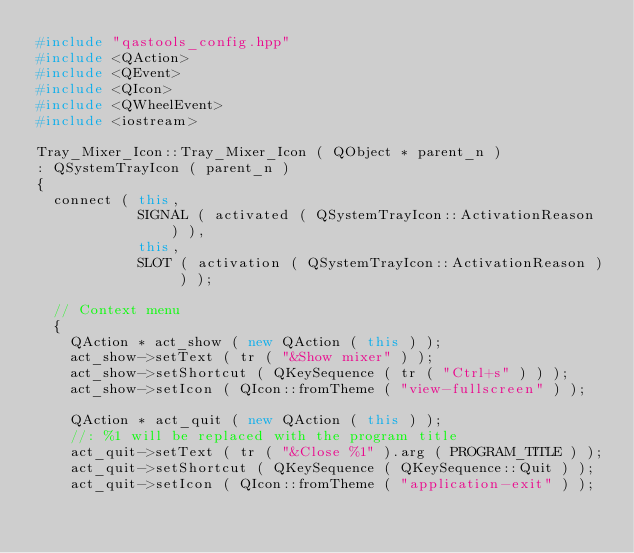<code> <loc_0><loc_0><loc_500><loc_500><_C++_>#include "qastools_config.hpp"
#include <QAction>
#include <QEvent>
#include <QIcon>
#include <QWheelEvent>
#include <iostream>

Tray_Mixer_Icon::Tray_Mixer_Icon ( QObject * parent_n )
: QSystemTrayIcon ( parent_n )
{
  connect ( this,
            SIGNAL ( activated ( QSystemTrayIcon::ActivationReason ) ),
            this,
            SLOT ( activation ( QSystemTrayIcon::ActivationReason ) ) );

  // Context menu
  {
    QAction * act_show ( new QAction ( this ) );
    act_show->setText ( tr ( "&Show mixer" ) );
    act_show->setShortcut ( QKeySequence ( tr ( "Ctrl+s" ) ) );
    act_show->setIcon ( QIcon::fromTheme ( "view-fullscreen" ) );

    QAction * act_quit ( new QAction ( this ) );
    //: %1 will be replaced with the program title
    act_quit->setText ( tr ( "&Close %1" ).arg ( PROGRAM_TITLE ) );
    act_quit->setShortcut ( QKeySequence ( QKeySequence::Quit ) );
    act_quit->setIcon ( QIcon::fromTheme ( "application-exit" ) );
</code> 